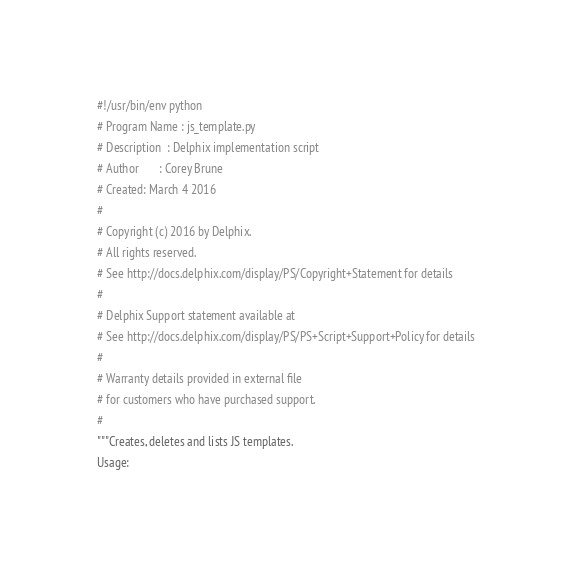Convert code to text. <code><loc_0><loc_0><loc_500><loc_500><_Python_>#!/usr/bin/env python
# Program Name : js_template.py
# Description  : Delphix implementation script
# Author       : Corey Brune
# Created: March 4 2016
#
# Copyright (c) 2016 by Delphix.
# All rights reserved.
# See http://docs.delphix.com/display/PS/Copyright+Statement for details
#
# Delphix Support statement available at
# See http://docs.delphix.com/display/PS/PS+Script+Support+Policy for details
#
# Warranty details provided in external file
# for customers who have purchased support.
#
"""Creates, deletes and lists JS templates.
Usage:</code> 